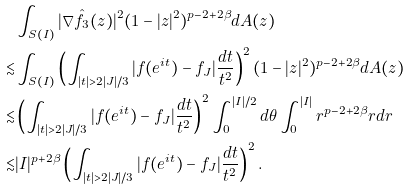Convert formula to latex. <formula><loc_0><loc_0><loc_500><loc_500>& \int _ { S ( I ) } | \nabla \hat { f _ { 3 } } ( z ) | ^ { 2 } ( 1 - | z | ^ { 2 } ) ^ { p - 2 + 2 \beta } d A ( z ) \\ \lesssim & \int _ { S ( I ) } \left ( \int _ { | t | > 2 | J | / 3 } | f ( e ^ { i t } ) - f _ { J } | \frac { d t } { t ^ { 2 } } \right ) ^ { 2 } ( 1 - | z | ^ { 2 } ) ^ { p - 2 + 2 \beta } d A ( z ) \\ \lesssim & \left ( \int _ { | t | > 2 | J | / 3 } | f ( e ^ { i t } ) - f _ { J } | \frac { d t } { t ^ { 2 } } \right ) ^ { 2 } \int _ { 0 } ^ { | I | / 2 } d \theta \int _ { 0 } ^ { | I | } r ^ { p - 2 + 2 \beta } r d r \\ \lesssim & | I | ^ { p + 2 \beta } \left ( \int _ { | t | > 2 | J | / 3 } | f ( e ^ { i t } ) - f _ { J } | \frac { d t } { t ^ { 2 } } \right ) ^ { 2 } .</formula> 